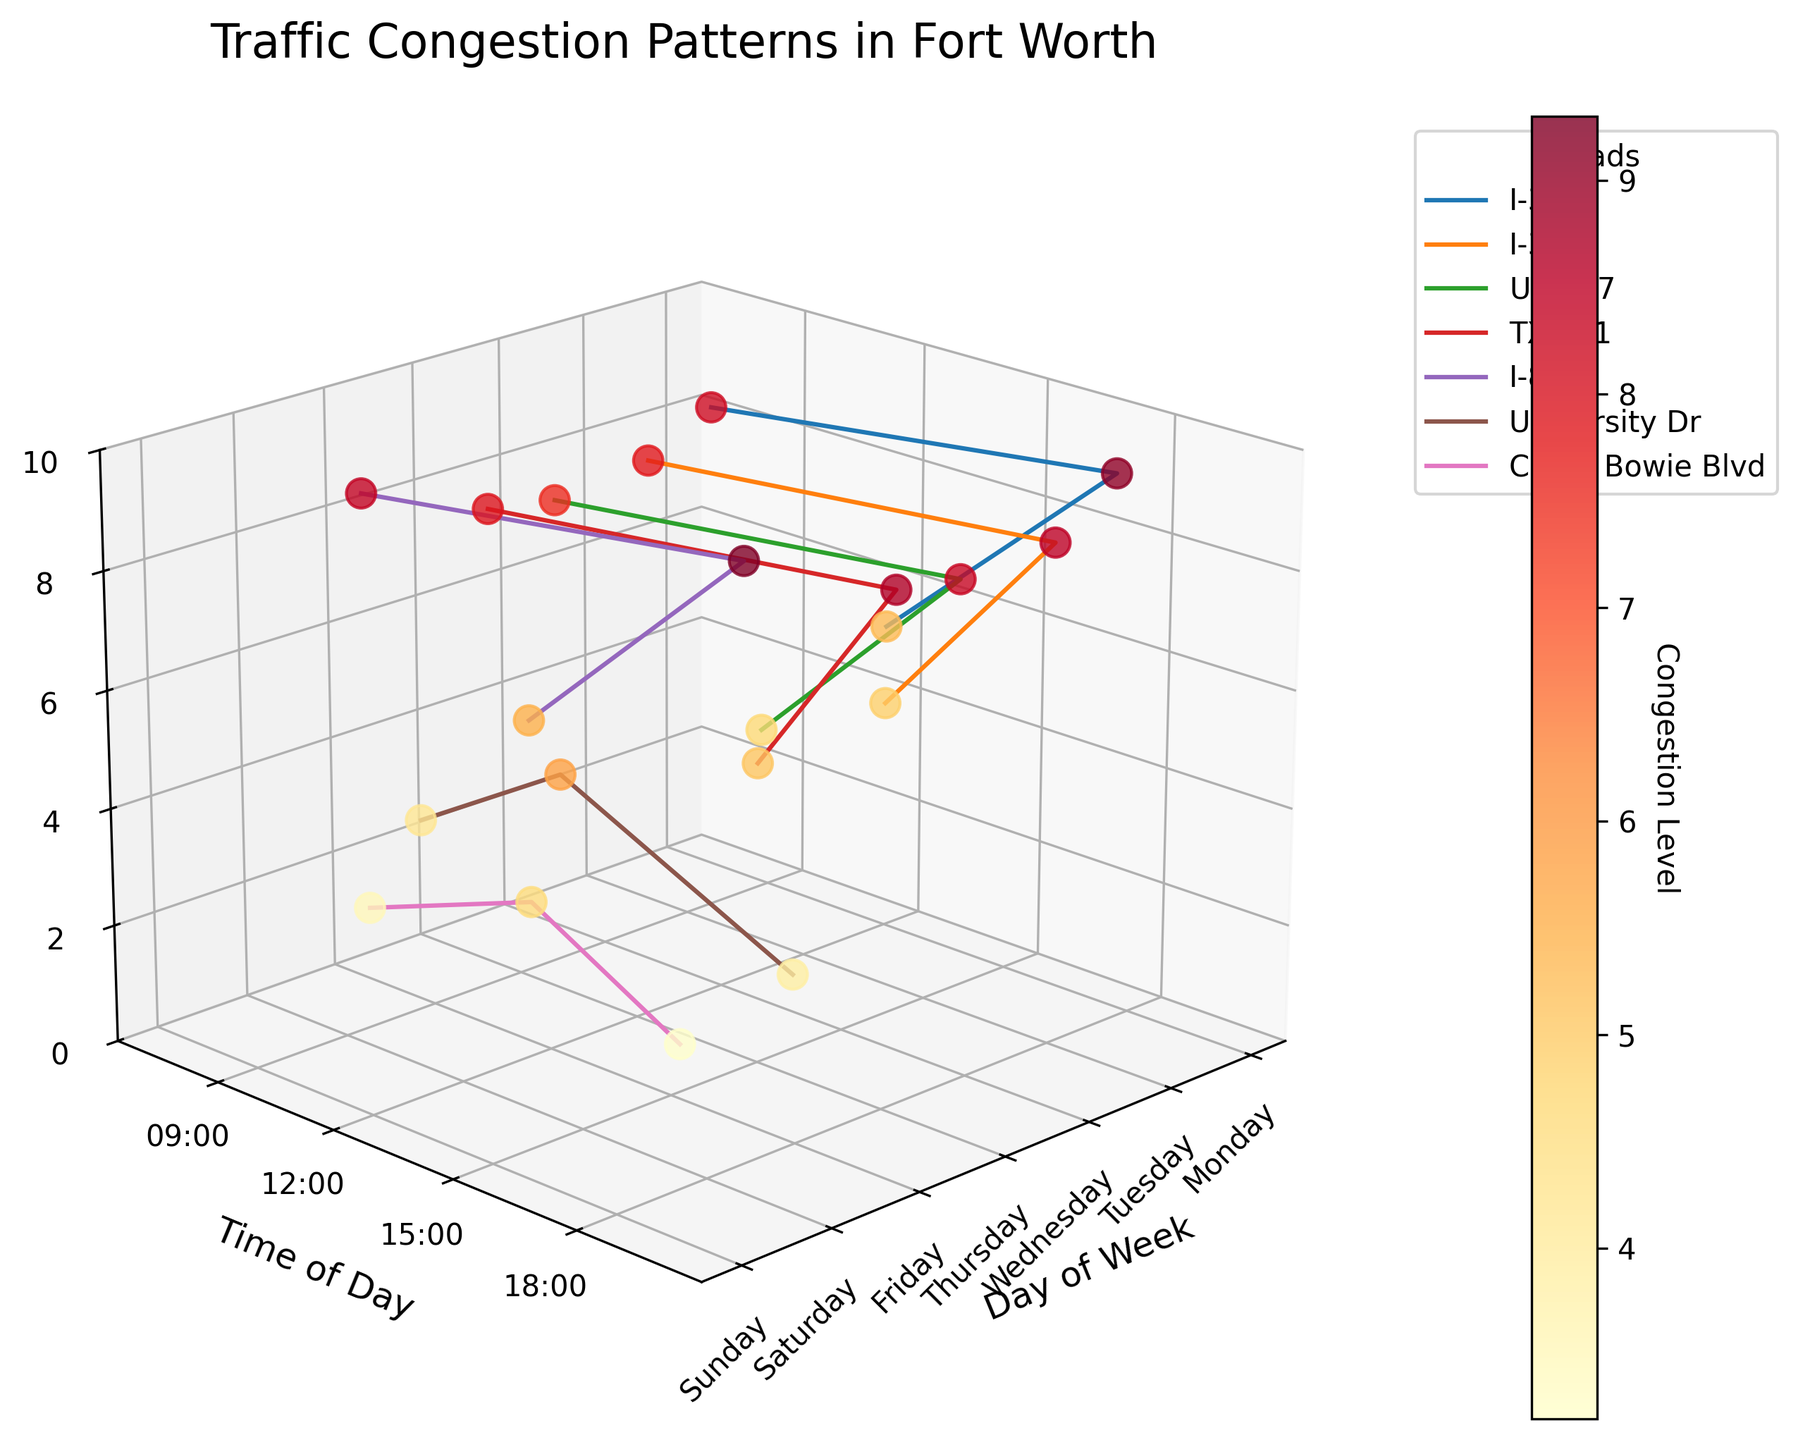Is the congestion level consistently higher during the mornings or the evenings? To determine whether mornings or evenings have higher congestion levels, observe the 3D plot points categorized by time of day, focusing on morning times (around 7:00-8:30) and evening times (around 16:30-18:15). Visualize the color gradient and height in both time periods.
Answer: Evenings Which day has the highest congestion level recorded? Examine the z-axis showing congestion levels across all days and identify the tallest point. The day corresponding to this tallest point represents the highest congestion level.
Answer: Friday On which road does the highest congestion level occur, and at what time of day? Identify the highest point on the z-axis. Trace back along the x-axis (days) and look at the associated marker's y-axis (time) and road label in the legend.
Answer: I-820, Friday, 16:45 What is the average congestion level for University Dr on Saturday? Locate the points for University Dr on Saturday. Sum the congestion levels and divide by the number of points. (4.2 + 5.8 + 3.9) / 3 = 4.63
Answer: 4.63 How does the congestion level vary between weekdays and weekends? Compare the data points from Monday to Friday (weekdays) with those from Saturday and Sunday (weekends). Observe the differences in congestion levels and dispersion across the times and road sections.
Answer: Higher on weekdays Which specific time on Monday has the lowest congestion level? Identify and compare all Monday data points on the plot, focusing on their height (z-axis values).
Answer: 12:00 Are there any particular trends observable in congestion levels across different days of the week? Observe each day's trend in terms of z-axis values and line patterns connecting the points. Look for increases, decreases, or any repeating patterns throughout the week.
Answer: Increase towards Friday, decrease on weekends What is the congestion level on Camp Bowie Blvd on Sunday at 19:30? Locate the specific data point for Camp Bowie Blvd on Sunday at 19:30 by following the legend and axes.
Answer: 3.2 Which road shows the highest variability in congestion levels? Analyze the road-specific lines plotted. Measure the range between the highest and lowest points for each road to determine variability.
Answer: University Dr When comparing I-35W and I-30, which road has higher congestion levels on Tuesday? Focus on the data points for I-35W and I-30 for Tuesday. Compare their heights (z-axis values) to determine which one is higher.
Answer: I-30 